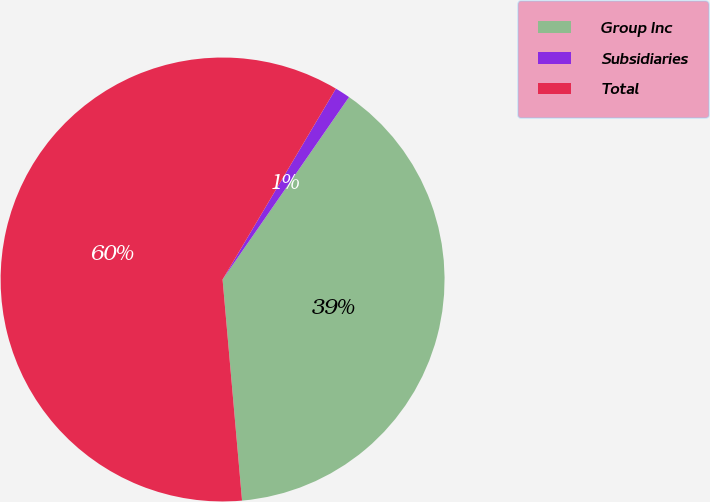Convert chart. <chart><loc_0><loc_0><loc_500><loc_500><pie_chart><fcel>Group Inc<fcel>Subsidiaries<fcel>Total<nl><fcel>38.95%<fcel>1.12%<fcel>59.92%<nl></chart> 